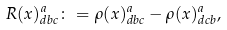<formula> <loc_0><loc_0><loc_500><loc_500>R ( x ) ^ { a } _ { d b c } \colon = \rho ( x ) ^ { a } _ { d b c } - \rho ( x ) ^ { a } _ { d c b } ,</formula> 